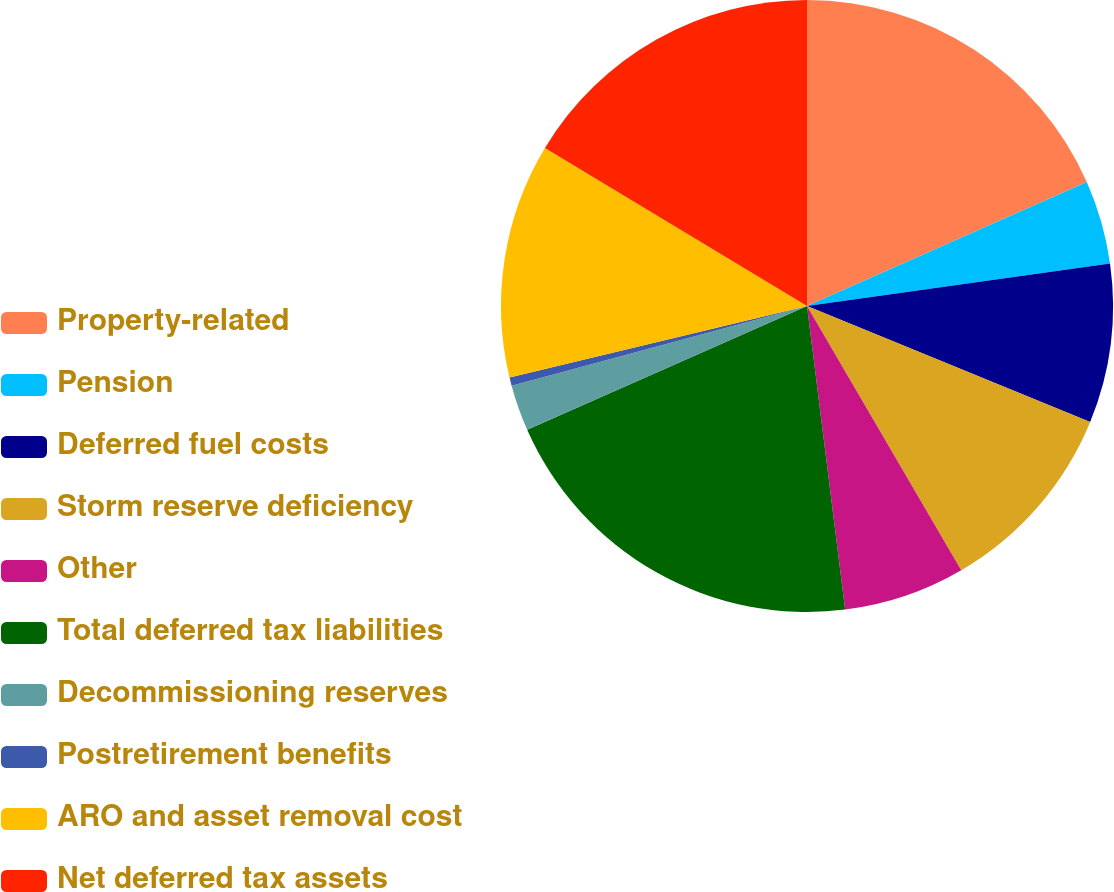Convert chart to OTSL. <chart><loc_0><loc_0><loc_500><loc_500><pie_chart><fcel>Property-related<fcel>Pension<fcel>Deferred fuel costs<fcel>Storm reserve deficiency<fcel>Other<fcel>Total deferred tax liabilities<fcel>Decommissioning reserves<fcel>Postretirement benefits<fcel>ARO and asset removal cost<fcel>Net deferred tax assets<nl><fcel>18.36%<fcel>4.42%<fcel>8.41%<fcel>10.4%<fcel>6.42%<fcel>20.36%<fcel>2.43%<fcel>0.44%<fcel>12.39%<fcel>16.37%<nl></chart> 